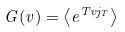Convert formula to latex. <formula><loc_0><loc_0><loc_500><loc_500>G ( v ) = \left < e ^ { T v j _ { T } } \right ></formula> 